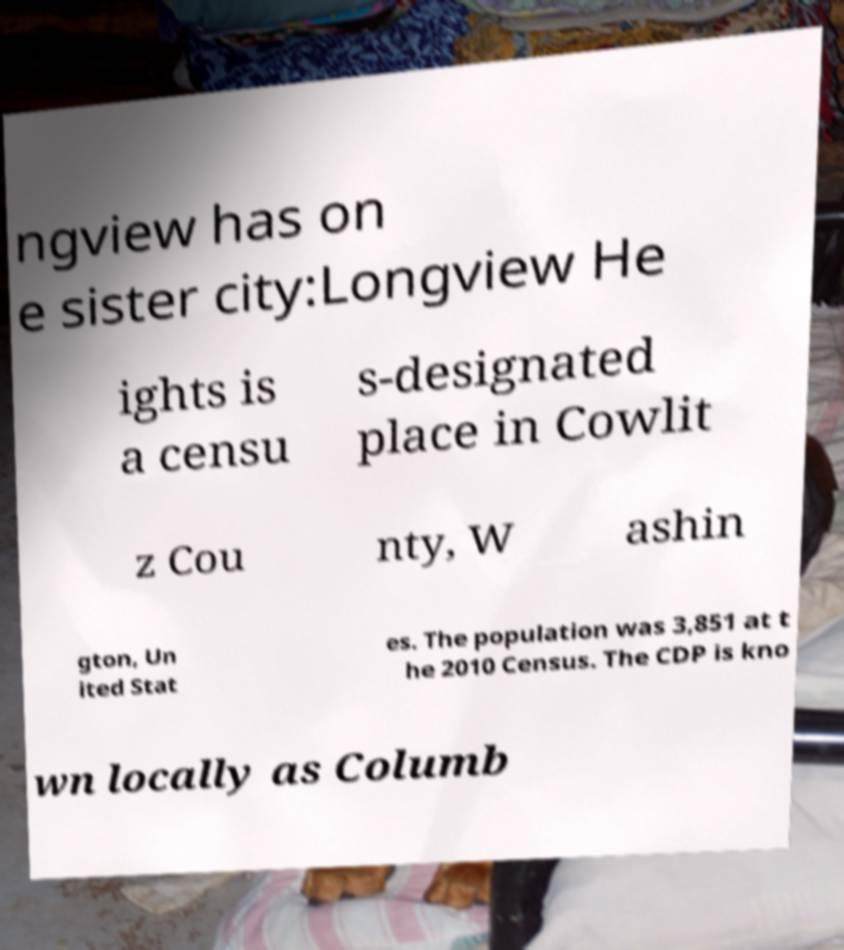Can you read and provide the text displayed in the image?This photo seems to have some interesting text. Can you extract and type it out for me? ngview has on e sister city:Longview He ights is a censu s-designated place in Cowlit z Cou nty, W ashin gton, Un ited Stat es. The population was 3,851 at t he 2010 Census. The CDP is kno wn locally as Columb 